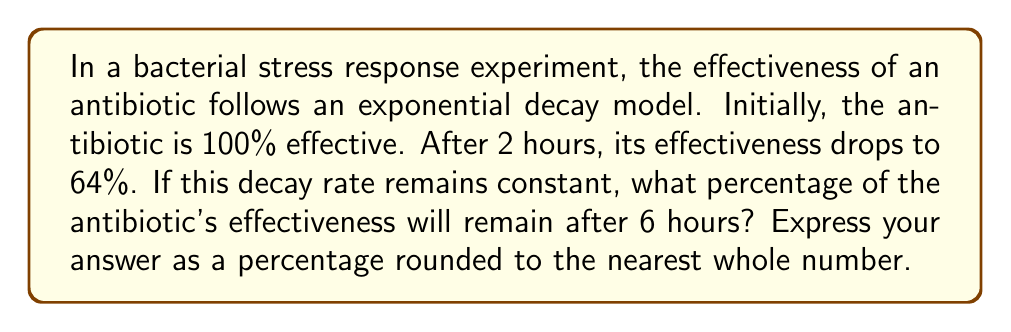Could you help me with this problem? Let's approach this step-by-step:

1) The exponential decay model is given by the equation:
   $$ A(t) = A_0 \cdot e^{-kt} $$
   where $A(t)$ is the effectiveness at time $t$, $A_0$ is the initial effectiveness, $k$ is the decay constant, and $t$ is time.

2) We know:
   - $A_0 = 100\%$ (initial effectiveness)
   - $A(2) = 64\%$ (effectiveness after 2 hours)
   - We need to find $A(6)$

3) Let's find the decay constant $k$ using the given information:
   $$ 64 = 100 \cdot e^{-2k} $$

4) Dividing both sides by 100:
   $$ 0.64 = e^{-2k} $$

5) Taking natural log of both sides:
   $$ \ln(0.64) = -2k $$

6) Solving for $k$:
   $$ k = -\frac{\ln(0.64)}{2} \approx 0.2231 $$

7) Now that we have $k$, we can find the effectiveness after 6 hours:
   $$ A(6) = 100 \cdot e^{-0.2231 \cdot 6} $$

8) Calculating:
   $$ A(6) = 100 \cdot e^{-1.3386} \approx 26.2144\% $$

9) Rounding to the nearest whole number:
   $$ A(6) \approx 26\% $$
Answer: 26% 